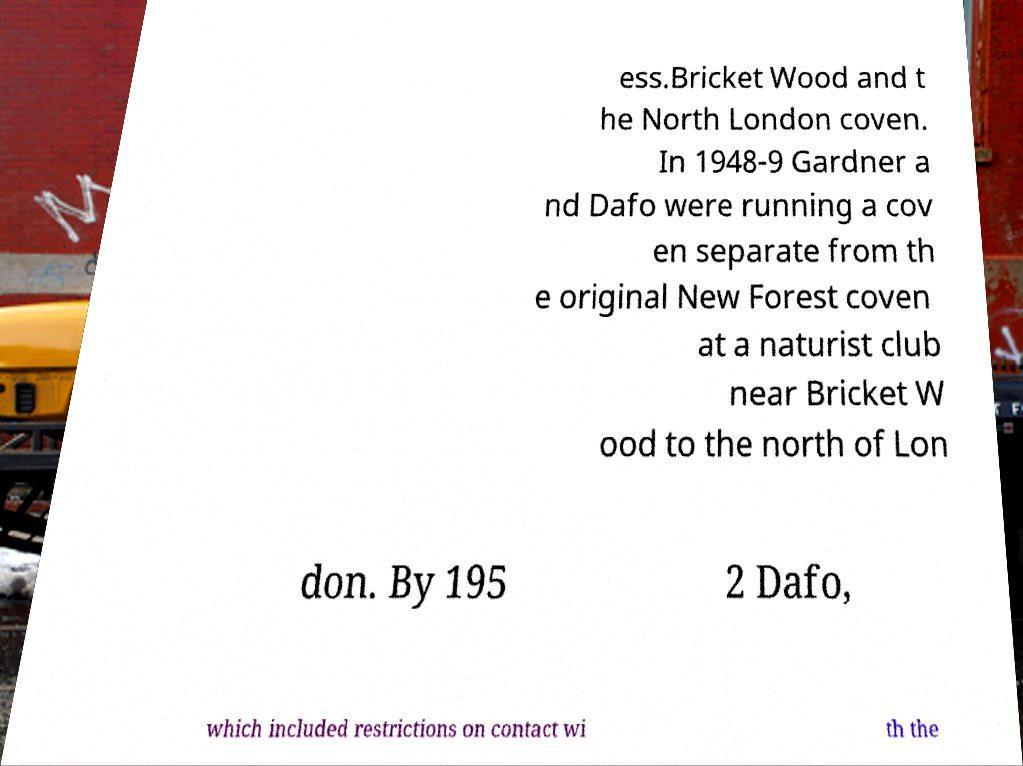Can you read and provide the text displayed in the image?This photo seems to have some interesting text. Can you extract and type it out for me? ess.Bricket Wood and t he North London coven. In 1948-9 Gardner a nd Dafo were running a cov en separate from th e original New Forest coven at a naturist club near Bricket W ood to the north of Lon don. By 195 2 Dafo, which included restrictions on contact wi th the 